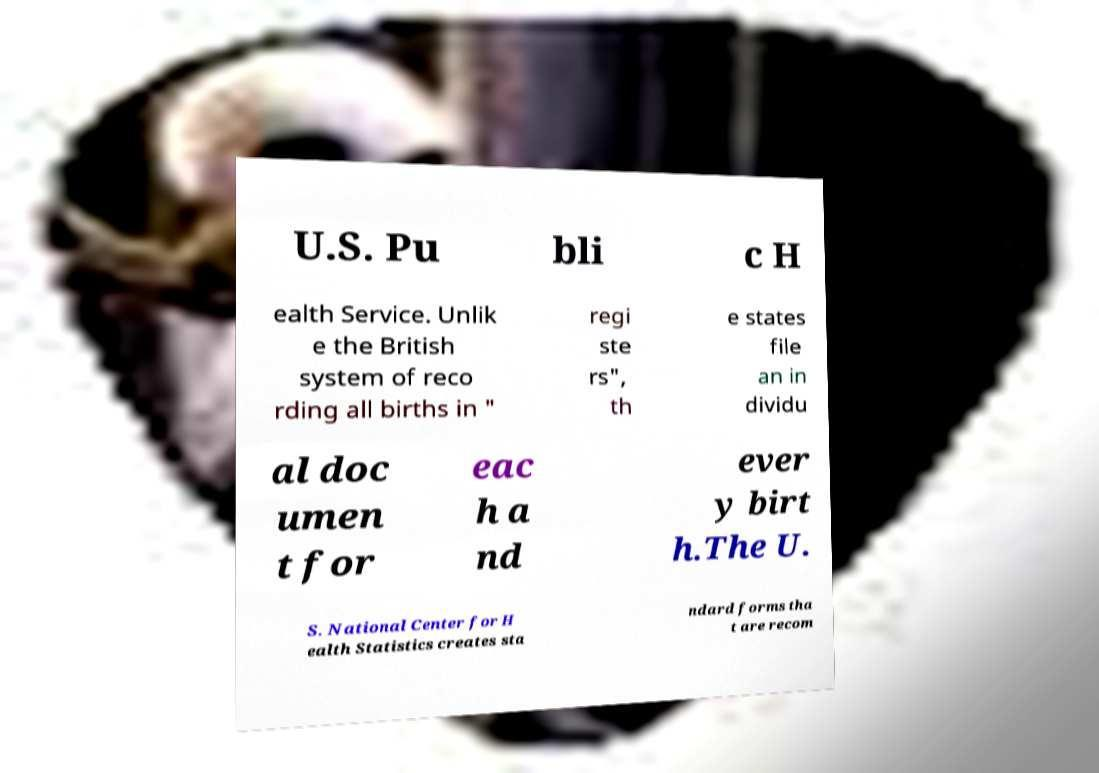What messages or text are displayed in this image? I need them in a readable, typed format. U.S. Pu bli c H ealth Service. Unlik e the British system of reco rding all births in " regi ste rs", th e states file an in dividu al doc umen t for eac h a nd ever y birt h.The U. S. National Center for H ealth Statistics creates sta ndard forms tha t are recom 